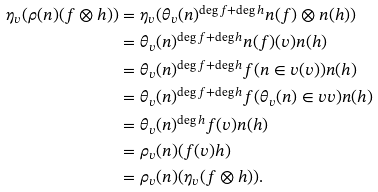<formula> <loc_0><loc_0><loc_500><loc_500>\eta _ { v } ( \rho ( n ) ( f \otimes h ) ) & = \eta _ { v } ( \theta _ { v } ( n ) ^ { \deg f + \deg h } n ( f ) \otimes n ( h ) ) \\ & = \theta _ { v } ( n ) ^ { \deg f + \deg h } n ( f ) ( v ) n ( h ) \\ & = \theta _ { v } ( n ) ^ { \deg f + \deg h } f ( n \in v ( v ) ) n ( h ) \\ & = \theta _ { v } ( n ) ^ { \deg f + \deg h } f ( \theta _ { v } ( n ) \in v v ) n ( h ) \\ & = \theta _ { v } ( n ) ^ { \deg h } f ( v ) n ( h ) \\ & = \rho _ { v } ( n ) ( f ( v ) h ) \\ & = \rho _ { v } ( n ) ( \eta _ { v } ( f \otimes h ) ) . \\</formula> 